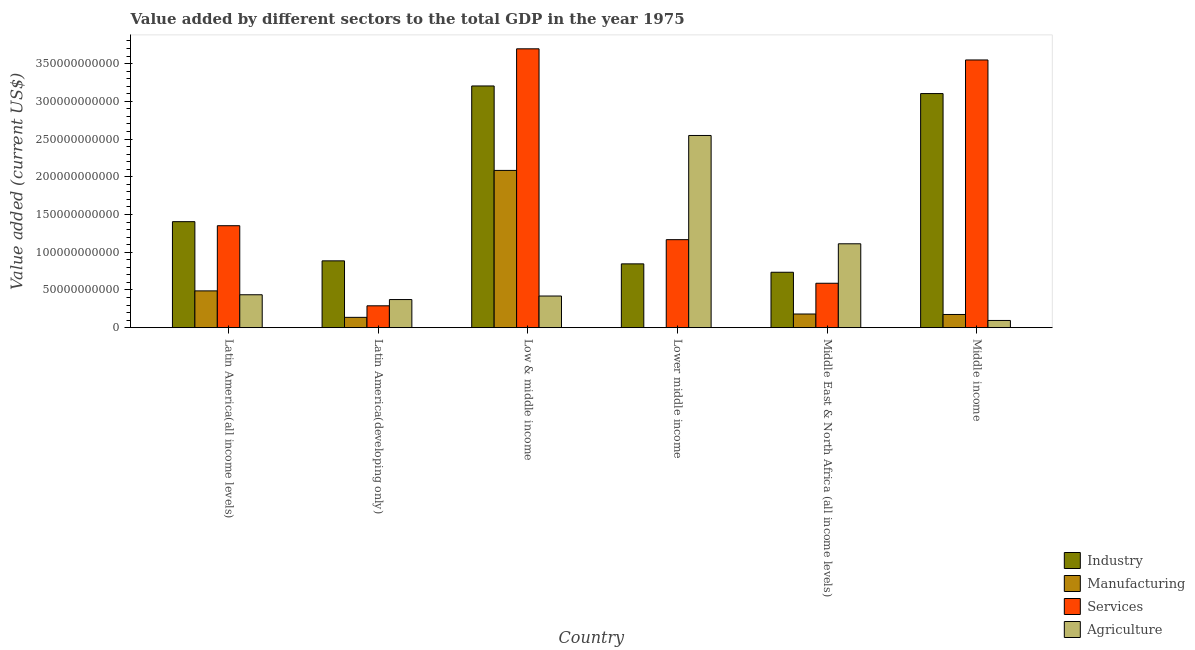How many different coloured bars are there?
Make the answer very short. 4. How many bars are there on the 4th tick from the left?
Your response must be concise. 4. How many bars are there on the 4th tick from the right?
Offer a terse response. 4. What is the label of the 4th group of bars from the left?
Your response must be concise. Lower middle income. In how many cases, is the number of bars for a given country not equal to the number of legend labels?
Offer a very short reply. 0. What is the value added by agricultural sector in Middle income?
Provide a short and direct response. 9.55e+09. Across all countries, what is the maximum value added by services sector?
Your response must be concise. 3.70e+11. Across all countries, what is the minimum value added by manufacturing sector?
Offer a very short reply. 9.84e+07. In which country was the value added by manufacturing sector maximum?
Ensure brevity in your answer.  Low & middle income. In which country was the value added by manufacturing sector minimum?
Offer a terse response. Lower middle income. What is the total value added by manufacturing sector in the graph?
Provide a short and direct response. 3.06e+11. What is the difference between the value added by industrial sector in Latin America(all income levels) and that in Middle East & North Africa (all income levels)?
Give a very brief answer. 6.70e+1. What is the difference between the value added by services sector in Lower middle income and the value added by agricultural sector in Low & middle income?
Provide a succinct answer. 7.47e+1. What is the average value added by manufacturing sector per country?
Keep it short and to the point. 5.11e+1. What is the difference between the value added by manufacturing sector and value added by industrial sector in Lower middle income?
Your answer should be very brief. -8.45e+1. In how many countries, is the value added by services sector greater than 370000000000 US$?
Ensure brevity in your answer.  0. What is the ratio of the value added by industrial sector in Low & middle income to that in Lower middle income?
Keep it short and to the point. 3.79. What is the difference between the highest and the second highest value added by manufacturing sector?
Ensure brevity in your answer.  1.60e+11. What is the difference between the highest and the lowest value added by manufacturing sector?
Keep it short and to the point. 2.08e+11. Is it the case that in every country, the sum of the value added by industrial sector and value added by manufacturing sector is greater than the sum of value added by agricultural sector and value added by services sector?
Provide a short and direct response. Yes. What does the 2nd bar from the left in Low & middle income represents?
Make the answer very short. Manufacturing. What does the 3rd bar from the right in Low & middle income represents?
Your answer should be compact. Manufacturing. Is it the case that in every country, the sum of the value added by industrial sector and value added by manufacturing sector is greater than the value added by services sector?
Make the answer very short. No. How many bars are there?
Your answer should be compact. 24. Are all the bars in the graph horizontal?
Your response must be concise. No. How many countries are there in the graph?
Your answer should be compact. 6. Are the values on the major ticks of Y-axis written in scientific E-notation?
Your answer should be compact. No. Does the graph contain grids?
Keep it short and to the point. No. How are the legend labels stacked?
Offer a very short reply. Vertical. What is the title of the graph?
Ensure brevity in your answer.  Value added by different sectors to the total GDP in the year 1975. Does "Luxembourg" appear as one of the legend labels in the graph?
Give a very brief answer. No. What is the label or title of the Y-axis?
Give a very brief answer. Value added (current US$). What is the Value added (current US$) in Industry in Latin America(all income levels)?
Provide a short and direct response. 1.40e+11. What is the Value added (current US$) of Manufacturing in Latin America(all income levels)?
Ensure brevity in your answer.  4.87e+1. What is the Value added (current US$) in Services in Latin America(all income levels)?
Keep it short and to the point. 1.35e+11. What is the Value added (current US$) of Agriculture in Latin America(all income levels)?
Keep it short and to the point. 4.36e+1. What is the Value added (current US$) of Industry in Latin America(developing only)?
Provide a short and direct response. 8.85e+1. What is the Value added (current US$) in Manufacturing in Latin America(developing only)?
Provide a short and direct response. 1.37e+1. What is the Value added (current US$) of Services in Latin America(developing only)?
Give a very brief answer. 2.90e+1. What is the Value added (current US$) of Agriculture in Latin America(developing only)?
Your answer should be compact. 3.73e+1. What is the Value added (current US$) in Industry in Low & middle income?
Provide a short and direct response. 3.20e+11. What is the Value added (current US$) in Manufacturing in Low & middle income?
Ensure brevity in your answer.  2.08e+11. What is the Value added (current US$) in Services in Low & middle income?
Your answer should be very brief. 3.70e+11. What is the Value added (current US$) of Agriculture in Low & middle income?
Ensure brevity in your answer.  4.19e+1. What is the Value added (current US$) of Industry in Lower middle income?
Give a very brief answer. 8.45e+1. What is the Value added (current US$) in Manufacturing in Lower middle income?
Your answer should be very brief. 9.84e+07. What is the Value added (current US$) in Services in Lower middle income?
Your answer should be compact. 1.17e+11. What is the Value added (current US$) in Agriculture in Lower middle income?
Ensure brevity in your answer.  2.55e+11. What is the Value added (current US$) in Industry in Middle East & North Africa (all income levels)?
Offer a very short reply. 7.34e+1. What is the Value added (current US$) of Manufacturing in Middle East & North Africa (all income levels)?
Make the answer very short. 1.81e+1. What is the Value added (current US$) in Services in Middle East & North Africa (all income levels)?
Give a very brief answer. 5.88e+1. What is the Value added (current US$) of Agriculture in Middle East & North Africa (all income levels)?
Your answer should be very brief. 1.11e+11. What is the Value added (current US$) of Industry in Middle income?
Provide a succinct answer. 3.10e+11. What is the Value added (current US$) of Manufacturing in Middle income?
Your answer should be very brief. 1.75e+1. What is the Value added (current US$) in Services in Middle income?
Your answer should be compact. 3.55e+11. What is the Value added (current US$) in Agriculture in Middle income?
Provide a short and direct response. 9.55e+09. Across all countries, what is the maximum Value added (current US$) in Industry?
Ensure brevity in your answer.  3.20e+11. Across all countries, what is the maximum Value added (current US$) of Manufacturing?
Your answer should be compact. 2.08e+11. Across all countries, what is the maximum Value added (current US$) in Services?
Your answer should be very brief. 3.70e+11. Across all countries, what is the maximum Value added (current US$) of Agriculture?
Keep it short and to the point. 2.55e+11. Across all countries, what is the minimum Value added (current US$) of Industry?
Provide a short and direct response. 7.34e+1. Across all countries, what is the minimum Value added (current US$) in Manufacturing?
Your response must be concise. 9.84e+07. Across all countries, what is the minimum Value added (current US$) of Services?
Your answer should be compact. 2.90e+1. Across all countries, what is the minimum Value added (current US$) in Agriculture?
Ensure brevity in your answer.  9.55e+09. What is the total Value added (current US$) in Industry in the graph?
Offer a terse response. 1.02e+12. What is the total Value added (current US$) of Manufacturing in the graph?
Ensure brevity in your answer.  3.06e+11. What is the total Value added (current US$) of Services in the graph?
Offer a very short reply. 1.06e+12. What is the total Value added (current US$) in Agriculture in the graph?
Offer a terse response. 4.98e+11. What is the difference between the Value added (current US$) in Industry in Latin America(all income levels) and that in Latin America(developing only)?
Your response must be concise. 5.19e+1. What is the difference between the Value added (current US$) of Manufacturing in Latin America(all income levels) and that in Latin America(developing only)?
Keep it short and to the point. 3.51e+1. What is the difference between the Value added (current US$) in Services in Latin America(all income levels) and that in Latin America(developing only)?
Ensure brevity in your answer.  1.06e+11. What is the difference between the Value added (current US$) of Agriculture in Latin America(all income levels) and that in Latin America(developing only)?
Keep it short and to the point. 6.36e+09. What is the difference between the Value added (current US$) in Industry in Latin America(all income levels) and that in Low & middle income?
Offer a terse response. -1.80e+11. What is the difference between the Value added (current US$) in Manufacturing in Latin America(all income levels) and that in Low & middle income?
Give a very brief answer. -1.60e+11. What is the difference between the Value added (current US$) of Services in Latin America(all income levels) and that in Low & middle income?
Offer a very short reply. -2.34e+11. What is the difference between the Value added (current US$) of Agriculture in Latin America(all income levels) and that in Low & middle income?
Offer a very short reply. 1.69e+09. What is the difference between the Value added (current US$) of Industry in Latin America(all income levels) and that in Lower middle income?
Give a very brief answer. 5.59e+1. What is the difference between the Value added (current US$) in Manufacturing in Latin America(all income levels) and that in Lower middle income?
Ensure brevity in your answer.  4.86e+1. What is the difference between the Value added (current US$) of Services in Latin America(all income levels) and that in Lower middle income?
Give a very brief answer. 1.85e+1. What is the difference between the Value added (current US$) of Agriculture in Latin America(all income levels) and that in Lower middle income?
Your response must be concise. -2.11e+11. What is the difference between the Value added (current US$) of Industry in Latin America(all income levels) and that in Middle East & North Africa (all income levels)?
Provide a short and direct response. 6.70e+1. What is the difference between the Value added (current US$) of Manufacturing in Latin America(all income levels) and that in Middle East & North Africa (all income levels)?
Your answer should be compact. 3.06e+1. What is the difference between the Value added (current US$) in Services in Latin America(all income levels) and that in Middle East & North Africa (all income levels)?
Your answer should be very brief. 7.63e+1. What is the difference between the Value added (current US$) of Agriculture in Latin America(all income levels) and that in Middle East & North Africa (all income levels)?
Provide a succinct answer. -6.75e+1. What is the difference between the Value added (current US$) in Industry in Latin America(all income levels) and that in Middle income?
Make the answer very short. -1.70e+11. What is the difference between the Value added (current US$) of Manufacturing in Latin America(all income levels) and that in Middle income?
Your response must be concise. 3.13e+1. What is the difference between the Value added (current US$) in Services in Latin America(all income levels) and that in Middle income?
Your response must be concise. -2.20e+11. What is the difference between the Value added (current US$) in Agriculture in Latin America(all income levels) and that in Middle income?
Offer a terse response. 3.41e+1. What is the difference between the Value added (current US$) of Industry in Latin America(developing only) and that in Low & middle income?
Give a very brief answer. -2.32e+11. What is the difference between the Value added (current US$) in Manufacturing in Latin America(developing only) and that in Low & middle income?
Make the answer very short. -1.95e+11. What is the difference between the Value added (current US$) in Services in Latin America(developing only) and that in Low & middle income?
Your answer should be compact. -3.41e+11. What is the difference between the Value added (current US$) in Agriculture in Latin America(developing only) and that in Low & middle income?
Your response must be concise. -4.66e+09. What is the difference between the Value added (current US$) in Industry in Latin America(developing only) and that in Lower middle income?
Provide a succinct answer. 4.00e+09. What is the difference between the Value added (current US$) in Manufacturing in Latin America(developing only) and that in Lower middle income?
Provide a succinct answer. 1.36e+1. What is the difference between the Value added (current US$) of Services in Latin America(developing only) and that in Lower middle income?
Your answer should be very brief. -8.77e+1. What is the difference between the Value added (current US$) of Agriculture in Latin America(developing only) and that in Lower middle income?
Your answer should be very brief. -2.17e+11. What is the difference between the Value added (current US$) of Industry in Latin America(developing only) and that in Middle East & North Africa (all income levels)?
Your answer should be very brief. 1.51e+1. What is the difference between the Value added (current US$) of Manufacturing in Latin America(developing only) and that in Middle East & North Africa (all income levels)?
Your response must be concise. -4.45e+09. What is the difference between the Value added (current US$) of Services in Latin America(developing only) and that in Middle East & North Africa (all income levels)?
Give a very brief answer. -2.99e+1. What is the difference between the Value added (current US$) of Agriculture in Latin America(developing only) and that in Middle East & North Africa (all income levels)?
Give a very brief answer. -7.39e+1. What is the difference between the Value added (current US$) in Industry in Latin America(developing only) and that in Middle income?
Ensure brevity in your answer.  -2.22e+11. What is the difference between the Value added (current US$) in Manufacturing in Latin America(developing only) and that in Middle income?
Ensure brevity in your answer.  -3.83e+09. What is the difference between the Value added (current US$) in Services in Latin America(developing only) and that in Middle income?
Ensure brevity in your answer.  -3.26e+11. What is the difference between the Value added (current US$) in Agriculture in Latin America(developing only) and that in Middle income?
Your answer should be very brief. 2.77e+1. What is the difference between the Value added (current US$) of Industry in Low & middle income and that in Lower middle income?
Make the answer very short. 2.36e+11. What is the difference between the Value added (current US$) of Manufacturing in Low & middle income and that in Lower middle income?
Provide a short and direct response. 2.08e+11. What is the difference between the Value added (current US$) in Services in Low & middle income and that in Lower middle income?
Your answer should be very brief. 2.53e+11. What is the difference between the Value added (current US$) in Agriculture in Low & middle income and that in Lower middle income?
Your response must be concise. -2.13e+11. What is the difference between the Value added (current US$) of Industry in Low & middle income and that in Middle East & North Africa (all income levels)?
Make the answer very short. 2.47e+11. What is the difference between the Value added (current US$) of Manufacturing in Low & middle income and that in Middle East & North Africa (all income levels)?
Provide a succinct answer. 1.90e+11. What is the difference between the Value added (current US$) of Services in Low & middle income and that in Middle East & North Africa (all income levels)?
Provide a short and direct response. 3.11e+11. What is the difference between the Value added (current US$) in Agriculture in Low & middle income and that in Middle East & North Africa (all income levels)?
Offer a very short reply. -6.92e+1. What is the difference between the Value added (current US$) in Industry in Low & middle income and that in Middle income?
Make the answer very short. 1.01e+1. What is the difference between the Value added (current US$) of Manufacturing in Low & middle income and that in Middle income?
Give a very brief answer. 1.91e+11. What is the difference between the Value added (current US$) in Services in Low & middle income and that in Middle income?
Your answer should be compact. 1.48e+1. What is the difference between the Value added (current US$) of Agriculture in Low & middle income and that in Middle income?
Provide a short and direct response. 3.24e+1. What is the difference between the Value added (current US$) in Industry in Lower middle income and that in Middle East & North Africa (all income levels)?
Provide a succinct answer. 1.11e+1. What is the difference between the Value added (current US$) in Manufacturing in Lower middle income and that in Middle East & North Africa (all income levels)?
Offer a terse response. -1.80e+1. What is the difference between the Value added (current US$) of Services in Lower middle income and that in Middle East & North Africa (all income levels)?
Your answer should be compact. 5.78e+1. What is the difference between the Value added (current US$) in Agriculture in Lower middle income and that in Middle East & North Africa (all income levels)?
Offer a very short reply. 1.44e+11. What is the difference between the Value added (current US$) of Industry in Lower middle income and that in Middle income?
Provide a succinct answer. -2.26e+11. What is the difference between the Value added (current US$) of Manufacturing in Lower middle income and that in Middle income?
Offer a very short reply. -1.74e+1. What is the difference between the Value added (current US$) in Services in Lower middle income and that in Middle income?
Your response must be concise. -2.38e+11. What is the difference between the Value added (current US$) of Agriculture in Lower middle income and that in Middle income?
Provide a succinct answer. 2.45e+11. What is the difference between the Value added (current US$) of Industry in Middle East & North Africa (all income levels) and that in Middle income?
Your answer should be very brief. -2.37e+11. What is the difference between the Value added (current US$) in Manufacturing in Middle East & North Africa (all income levels) and that in Middle income?
Provide a succinct answer. 6.23e+08. What is the difference between the Value added (current US$) of Services in Middle East & North Africa (all income levels) and that in Middle income?
Your response must be concise. -2.96e+11. What is the difference between the Value added (current US$) in Agriculture in Middle East & North Africa (all income levels) and that in Middle income?
Provide a short and direct response. 1.02e+11. What is the difference between the Value added (current US$) of Industry in Latin America(all income levels) and the Value added (current US$) of Manufacturing in Latin America(developing only)?
Provide a succinct answer. 1.27e+11. What is the difference between the Value added (current US$) in Industry in Latin America(all income levels) and the Value added (current US$) in Services in Latin America(developing only)?
Your answer should be very brief. 1.12e+11. What is the difference between the Value added (current US$) in Industry in Latin America(all income levels) and the Value added (current US$) in Agriculture in Latin America(developing only)?
Ensure brevity in your answer.  1.03e+11. What is the difference between the Value added (current US$) in Manufacturing in Latin America(all income levels) and the Value added (current US$) in Services in Latin America(developing only)?
Your response must be concise. 1.98e+1. What is the difference between the Value added (current US$) in Manufacturing in Latin America(all income levels) and the Value added (current US$) in Agriculture in Latin America(developing only)?
Keep it short and to the point. 1.15e+1. What is the difference between the Value added (current US$) in Services in Latin America(all income levels) and the Value added (current US$) in Agriculture in Latin America(developing only)?
Offer a very short reply. 9.79e+1. What is the difference between the Value added (current US$) of Industry in Latin America(all income levels) and the Value added (current US$) of Manufacturing in Low & middle income?
Ensure brevity in your answer.  -6.79e+1. What is the difference between the Value added (current US$) in Industry in Latin America(all income levels) and the Value added (current US$) in Services in Low & middle income?
Your response must be concise. -2.29e+11. What is the difference between the Value added (current US$) in Industry in Latin America(all income levels) and the Value added (current US$) in Agriculture in Low & middle income?
Offer a terse response. 9.86e+1. What is the difference between the Value added (current US$) of Manufacturing in Latin America(all income levels) and the Value added (current US$) of Services in Low & middle income?
Keep it short and to the point. -3.21e+11. What is the difference between the Value added (current US$) in Manufacturing in Latin America(all income levels) and the Value added (current US$) in Agriculture in Low & middle income?
Offer a very short reply. 6.82e+09. What is the difference between the Value added (current US$) of Services in Latin America(all income levels) and the Value added (current US$) of Agriculture in Low & middle income?
Offer a terse response. 9.32e+1. What is the difference between the Value added (current US$) of Industry in Latin America(all income levels) and the Value added (current US$) of Manufacturing in Lower middle income?
Offer a very short reply. 1.40e+11. What is the difference between the Value added (current US$) of Industry in Latin America(all income levels) and the Value added (current US$) of Services in Lower middle income?
Make the answer very short. 2.39e+1. What is the difference between the Value added (current US$) of Industry in Latin America(all income levels) and the Value added (current US$) of Agriculture in Lower middle income?
Your answer should be compact. -1.14e+11. What is the difference between the Value added (current US$) of Manufacturing in Latin America(all income levels) and the Value added (current US$) of Services in Lower middle income?
Keep it short and to the point. -6.79e+1. What is the difference between the Value added (current US$) in Manufacturing in Latin America(all income levels) and the Value added (current US$) in Agriculture in Lower middle income?
Offer a terse response. -2.06e+11. What is the difference between the Value added (current US$) of Services in Latin America(all income levels) and the Value added (current US$) of Agriculture in Lower middle income?
Keep it short and to the point. -1.20e+11. What is the difference between the Value added (current US$) in Industry in Latin America(all income levels) and the Value added (current US$) in Manufacturing in Middle East & North Africa (all income levels)?
Give a very brief answer. 1.22e+11. What is the difference between the Value added (current US$) of Industry in Latin America(all income levels) and the Value added (current US$) of Services in Middle East & North Africa (all income levels)?
Your response must be concise. 8.16e+1. What is the difference between the Value added (current US$) of Industry in Latin America(all income levels) and the Value added (current US$) of Agriculture in Middle East & North Africa (all income levels)?
Your response must be concise. 2.93e+1. What is the difference between the Value added (current US$) in Manufacturing in Latin America(all income levels) and the Value added (current US$) in Services in Middle East & North Africa (all income levels)?
Your answer should be compact. -1.01e+1. What is the difference between the Value added (current US$) in Manufacturing in Latin America(all income levels) and the Value added (current US$) in Agriculture in Middle East & North Africa (all income levels)?
Your answer should be compact. -6.24e+1. What is the difference between the Value added (current US$) of Services in Latin America(all income levels) and the Value added (current US$) of Agriculture in Middle East & North Africa (all income levels)?
Ensure brevity in your answer.  2.40e+1. What is the difference between the Value added (current US$) in Industry in Latin America(all income levels) and the Value added (current US$) in Manufacturing in Middle income?
Offer a very short reply. 1.23e+11. What is the difference between the Value added (current US$) of Industry in Latin America(all income levels) and the Value added (current US$) of Services in Middle income?
Provide a short and direct response. -2.14e+11. What is the difference between the Value added (current US$) in Industry in Latin America(all income levels) and the Value added (current US$) in Agriculture in Middle income?
Make the answer very short. 1.31e+11. What is the difference between the Value added (current US$) of Manufacturing in Latin America(all income levels) and the Value added (current US$) of Services in Middle income?
Provide a short and direct response. -3.06e+11. What is the difference between the Value added (current US$) in Manufacturing in Latin America(all income levels) and the Value added (current US$) in Agriculture in Middle income?
Give a very brief answer. 3.92e+1. What is the difference between the Value added (current US$) of Services in Latin America(all income levels) and the Value added (current US$) of Agriculture in Middle income?
Offer a very short reply. 1.26e+11. What is the difference between the Value added (current US$) in Industry in Latin America(developing only) and the Value added (current US$) in Manufacturing in Low & middle income?
Your answer should be compact. -1.20e+11. What is the difference between the Value added (current US$) of Industry in Latin America(developing only) and the Value added (current US$) of Services in Low & middle income?
Your response must be concise. -2.81e+11. What is the difference between the Value added (current US$) in Industry in Latin America(developing only) and the Value added (current US$) in Agriculture in Low & middle income?
Offer a terse response. 4.66e+1. What is the difference between the Value added (current US$) in Manufacturing in Latin America(developing only) and the Value added (current US$) in Services in Low & middle income?
Ensure brevity in your answer.  -3.56e+11. What is the difference between the Value added (current US$) of Manufacturing in Latin America(developing only) and the Value added (current US$) of Agriculture in Low & middle income?
Offer a terse response. -2.83e+1. What is the difference between the Value added (current US$) in Services in Latin America(developing only) and the Value added (current US$) in Agriculture in Low & middle income?
Keep it short and to the point. -1.30e+1. What is the difference between the Value added (current US$) in Industry in Latin America(developing only) and the Value added (current US$) in Manufacturing in Lower middle income?
Your answer should be very brief. 8.85e+1. What is the difference between the Value added (current US$) in Industry in Latin America(developing only) and the Value added (current US$) in Services in Lower middle income?
Provide a succinct answer. -2.81e+1. What is the difference between the Value added (current US$) in Industry in Latin America(developing only) and the Value added (current US$) in Agriculture in Lower middle income?
Keep it short and to the point. -1.66e+11. What is the difference between the Value added (current US$) in Manufacturing in Latin America(developing only) and the Value added (current US$) in Services in Lower middle income?
Your response must be concise. -1.03e+11. What is the difference between the Value added (current US$) of Manufacturing in Latin America(developing only) and the Value added (current US$) of Agriculture in Lower middle income?
Your answer should be compact. -2.41e+11. What is the difference between the Value added (current US$) of Services in Latin America(developing only) and the Value added (current US$) of Agriculture in Lower middle income?
Keep it short and to the point. -2.26e+11. What is the difference between the Value added (current US$) of Industry in Latin America(developing only) and the Value added (current US$) of Manufacturing in Middle East & North Africa (all income levels)?
Provide a succinct answer. 7.04e+1. What is the difference between the Value added (current US$) of Industry in Latin America(developing only) and the Value added (current US$) of Services in Middle East & North Africa (all income levels)?
Keep it short and to the point. 2.97e+1. What is the difference between the Value added (current US$) of Industry in Latin America(developing only) and the Value added (current US$) of Agriculture in Middle East & North Africa (all income levels)?
Offer a very short reply. -2.26e+1. What is the difference between the Value added (current US$) in Manufacturing in Latin America(developing only) and the Value added (current US$) in Services in Middle East & North Africa (all income levels)?
Offer a terse response. -4.52e+1. What is the difference between the Value added (current US$) in Manufacturing in Latin America(developing only) and the Value added (current US$) in Agriculture in Middle East & North Africa (all income levels)?
Keep it short and to the point. -9.75e+1. What is the difference between the Value added (current US$) of Services in Latin America(developing only) and the Value added (current US$) of Agriculture in Middle East & North Africa (all income levels)?
Keep it short and to the point. -8.22e+1. What is the difference between the Value added (current US$) of Industry in Latin America(developing only) and the Value added (current US$) of Manufacturing in Middle income?
Ensure brevity in your answer.  7.11e+1. What is the difference between the Value added (current US$) in Industry in Latin America(developing only) and the Value added (current US$) in Services in Middle income?
Offer a terse response. -2.66e+11. What is the difference between the Value added (current US$) of Industry in Latin America(developing only) and the Value added (current US$) of Agriculture in Middle income?
Provide a succinct answer. 7.90e+1. What is the difference between the Value added (current US$) of Manufacturing in Latin America(developing only) and the Value added (current US$) of Services in Middle income?
Make the answer very short. -3.41e+11. What is the difference between the Value added (current US$) of Manufacturing in Latin America(developing only) and the Value added (current US$) of Agriculture in Middle income?
Offer a very short reply. 4.10e+09. What is the difference between the Value added (current US$) of Services in Latin America(developing only) and the Value added (current US$) of Agriculture in Middle income?
Your answer should be compact. 1.94e+1. What is the difference between the Value added (current US$) of Industry in Low & middle income and the Value added (current US$) of Manufacturing in Lower middle income?
Offer a terse response. 3.20e+11. What is the difference between the Value added (current US$) in Industry in Low & middle income and the Value added (current US$) in Services in Lower middle income?
Keep it short and to the point. 2.04e+11. What is the difference between the Value added (current US$) of Industry in Low & middle income and the Value added (current US$) of Agriculture in Lower middle income?
Make the answer very short. 6.56e+1. What is the difference between the Value added (current US$) in Manufacturing in Low & middle income and the Value added (current US$) in Services in Lower middle income?
Make the answer very short. 9.18e+1. What is the difference between the Value added (current US$) of Manufacturing in Low & middle income and the Value added (current US$) of Agriculture in Lower middle income?
Your response must be concise. -4.63e+1. What is the difference between the Value added (current US$) in Services in Low & middle income and the Value added (current US$) in Agriculture in Lower middle income?
Make the answer very short. 1.15e+11. What is the difference between the Value added (current US$) of Industry in Low & middle income and the Value added (current US$) of Manufacturing in Middle East & North Africa (all income levels)?
Make the answer very short. 3.02e+11. What is the difference between the Value added (current US$) in Industry in Low & middle income and the Value added (current US$) in Services in Middle East & North Africa (all income levels)?
Provide a short and direct response. 2.61e+11. What is the difference between the Value added (current US$) of Industry in Low & middle income and the Value added (current US$) of Agriculture in Middle East & North Africa (all income levels)?
Your response must be concise. 2.09e+11. What is the difference between the Value added (current US$) in Manufacturing in Low & middle income and the Value added (current US$) in Services in Middle East & North Africa (all income levels)?
Make the answer very short. 1.50e+11. What is the difference between the Value added (current US$) in Manufacturing in Low & middle income and the Value added (current US$) in Agriculture in Middle East & North Africa (all income levels)?
Keep it short and to the point. 9.72e+1. What is the difference between the Value added (current US$) in Services in Low & middle income and the Value added (current US$) in Agriculture in Middle East & North Africa (all income levels)?
Offer a very short reply. 2.58e+11. What is the difference between the Value added (current US$) in Industry in Low & middle income and the Value added (current US$) in Manufacturing in Middle income?
Provide a short and direct response. 3.03e+11. What is the difference between the Value added (current US$) of Industry in Low & middle income and the Value added (current US$) of Services in Middle income?
Your answer should be compact. -3.45e+1. What is the difference between the Value added (current US$) of Industry in Low & middle income and the Value added (current US$) of Agriculture in Middle income?
Keep it short and to the point. 3.11e+11. What is the difference between the Value added (current US$) of Manufacturing in Low & middle income and the Value added (current US$) of Services in Middle income?
Provide a succinct answer. -1.46e+11. What is the difference between the Value added (current US$) in Manufacturing in Low & middle income and the Value added (current US$) in Agriculture in Middle income?
Give a very brief answer. 1.99e+11. What is the difference between the Value added (current US$) of Services in Low & middle income and the Value added (current US$) of Agriculture in Middle income?
Give a very brief answer. 3.60e+11. What is the difference between the Value added (current US$) in Industry in Lower middle income and the Value added (current US$) in Manufacturing in Middle East & North Africa (all income levels)?
Your response must be concise. 6.64e+1. What is the difference between the Value added (current US$) in Industry in Lower middle income and the Value added (current US$) in Services in Middle East & North Africa (all income levels)?
Your answer should be compact. 2.57e+1. What is the difference between the Value added (current US$) in Industry in Lower middle income and the Value added (current US$) in Agriculture in Middle East & North Africa (all income levels)?
Provide a short and direct response. -2.66e+1. What is the difference between the Value added (current US$) in Manufacturing in Lower middle income and the Value added (current US$) in Services in Middle East & North Africa (all income levels)?
Your response must be concise. -5.87e+1. What is the difference between the Value added (current US$) of Manufacturing in Lower middle income and the Value added (current US$) of Agriculture in Middle East & North Africa (all income levels)?
Make the answer very short. -1.11e+11. What is the difference between the Value added (current US$) in Services in Lower middle income and the Value added (current US$) in Agriculture in Middle East & North Africa (all income levels)?
Offer a very short reply. 5.47e+09. What is the difference between the Value added (current US$) of Industry in Lower middle income and the Value added (current US$) of Manufacturing in Middle income?
Your answer should be very brief. 6.71e+1. What is the difference between the Value added (current US$) of Industry in Lower middle income and the Value added (current US$) of Services in Middle income?
Give a very brief answer. -2.70e+11. What is the difference between the Value added (current US$) in Industry in Lower middle income and the Value added (current US$) in Agriculture in Middle income?
Make the answer very short. 7.50e+1. What is the difference between the Value added (current US$) of Manufacturing in Lower middle income and the Value added (current US$) of Services in Middle income?
Ensure brevity in your answer.  -3.55e+11. What is the difference between the Value added (current US$) in Manufacturing in Lower middle income and the Value added (current US$) in Agriculture in Middle income?
Give a very brief answer. -9.45e+09. What is the difference between the Value added (current US$) in Services in Lower middle income and the Value added (current US$) in Agriculture in Middle income?
Ensure brevity in your answer.  1.07e+11. What is the difference between the Value added (current US$) of Industry in Middle East & North Africa (all income levels) and the Value added (current US$) of Manufacturing in Middle income?
Your answer should be very brief. 5.59e+1. What is the difference between the Value added (current US$) of Industry in Middle East & North Africa (all income levels) and the Value added (current US$) of Services in Middle income?
Keep it short and to the point. -2.81e+11. What is the difference between the Value added (current US$) of Industry in Middle East & North Africa (all income levels) and the Value added (current US$) of Agriculture in Middle income?
Offer a terse response. 6.39e+1. What is the difference between the Value added (current US$) of Manufacturing in Middle East & North Africa (all income levels) and the Value added (current US$) of Services in Middle income?
Your answer should be compact. -3.37e+11. What is the difference between the Value added (current US$) in Manufacturing in Middle East & North Africa (all income levels) and the Value added (current US$) in Agriculture in Middle income?
Your response must be concise. 8.55e+09. What is the difference between the Value added (current US$) in Services in Middle East & North Africa (all income levels) and the Value added (current US$) in Agriculture in Middle income?
Offer a terse response. 4.93e+1. What is the average Value added (current US$) of Industry per country?
Ensure brevity in your answer.  1.70e+11. What is the average Value added (current US$) in Manufacturing per country?
Your answer should be very brief. 5.11e+1. What is the average Value added (current US$) in Services per country?
Your answer should be very brief. 1.77e+11. What is the average Value added (current US$) in Agriculture per country?
Give a very brief answer. 8.30e+1. What is the difference between the Value added (current US$) of Industry and Value added (current US$) of Manufacturing in Latin America(all income levels)?
Offer a very short reply. 9.17e+1. What is the difference between the Value added (current US$) of Industry and Value added (current US$) of Services in Latin America(all income levels)?
Give a very brief answer. 5.36e+09. What is the difference between the Value added (current US$) of Industry and Value added (current US$) of Agriculture in Latin America(all income levels)?
Ensure brevity in your answer.  9.69e+1. What is the difference between the Value added (current US$) of Manufacturing and Value added (current US$) of Services in Latin America(all income levels)?
Your answer should be compact. -8.64e+1. What is the difference between the Value added (current US$) in Manufacturing and Value added (current US$) in Agriculture in Latin America(all income levels)?
Ensure brevity in your answer.  5.13e+09. What is the difference between the Value added (current US$) of Services and Value added (current US$) of Agriculture in Latin America(all income levels)?
Keep it short and to the point. 9.15e+1. What is the difference between the Value added (current US$) in Industry and Value added (current US$) in Manufacturing in Latin America(developing only)?
Provide a succinct answer. 7.49e+1. What is the difference between the Value added (current US$) of Industry and Value added (current US$) of Services in Latin America(developing only)?
Keep it short and to the point. 5.96e+1. What is the difference between the Value added (current US$) of Industry and Value added (current US$) of Agriculture in Latin America(developing only)?
Keep it short and to the point. 5.13e+1. What is the difference between the Value added (current US$) in Manufacturing and Value added (current US$) in Services in Latin America(developing only)?
Your answer should be compact. -1.53e+1. What is the difference between the Value added (current US$) of Manufacturing and Value added (current US$) of Agriculture in Latin America(developing only)?
Provide a short and direct response. -2.36e+1. What is the difference between the Value added (current US$) of Services and Value added (current US$) of Agriculture in Latin America(developing only)?
Make the answer very short. -8.30e+09. What is the difference between the Value added (current US$) in Industry and Value added (current US$) in Manufacturing in Low & middle income?
Your answer should be compact. 1.12e+11. What is the difference between the Value added (current US$) in Industry and Value added (current US$) in Services in Low & middle income?
Provide a succinct answer. -4.92e+1. What is the difference between the Value added (current US$) of Industry and Value added (current US$) of Agriculture in Low & middle income?
Offer a terse response. 2.78e+11. What is the difference between the Value added (current US$) in Manufacturing and Value added (current US$) in Services in Low & middle income?
Your answer should be compact. -1.61e+11. What is the difference between the Value added (current US$) in Manufacturing and Value added (current US$) in Agriculture in Low & middle income?
Your response must be concise. 1.66e+11. What is the difference between the Value added (current US$) of Services and Value added (current US$) of Agriculture in Low & middle income?
Make the answer very short. 3.28e+11. What is the difference between the Value added (current US$) in Industry and Value added (current US$) in Manufacturing in Lower middle income?
Your answer should be very brief. 8.45e+1. What is the difference between the Value added (current US$) of Industry and Value added (current US$) of Services in Lower middle income?
Make the answer very short. -3.21e+1. What is the difference between the Value added (current US$) of Industry and Value added (current US$) of Agriculture in Lower middle income?
Ensure brevity in your answer.  -1.70e+11. What is the difference between the Value added (current US$) in Manufacturing and Value added (current US$) in Services in Lower middle income?
Offer a terse response. -1.17e+11. What is the difference between the Value added (current US$) of Manufacturing and Value added (current US$) of Agriculture in Lower middle income?
Your answer should be very brief. -2.55e+11. What is the difference between the Value added (current US$) of Services and Value added (current US$) of Agriculture in Lower middle income?
Your answer should be compact. -1.38e+11. What is the difference between the Value added (current US$) in Industry and Value added (current US$) in Manufacturing in Middle East & North Africa (all income levels)?
Provide a short and direct response. 5.53e+1. What is the difference between the Value added (current US$) of Industry and Value added (current US$) of Services in Middle East & North Africa (all income levels)?
Provide a succinct answer. 1.46e+1. What is the difference between the Value added (current US$) in Industry and Value added (current US$) in Agriculture in Middle East & North Africa (all income levels)?
Provide a short and direct response. -3.77e+1. What is the difference between the Value added (current US$) in Manufacturing and Value added (current US$) in Services in Middle East & North Africa (all income levels)?
Provide a short and direct response. -4.07e+1. What is the difference between the Value added (current US$) in Manufacturing and Value added (current US$) in Agriculture in Middle East & North Africa (all income levels)?
Offer a terse response. -9.30e+1. What is the difference between the Value added (current US$) of Services and Value added (current US$) of Agriculture in Middle East & North Africa (all income levels)?
Your answer should be compact. -5.23e+1. What is the difference between the Value added (current US$) in Industry and Value added (current US$) in Manufacturing in Middle income?
Offer a very short reply. 2.93e+11. What is the difference between the Value added (current US$) in Industry and Value added (current US$) in Services in Middle income?
Give a very brief answer. -4.45e+1. What is the difference between the Value added (current US$) of Industry and Value added (current US$) of Agriculture in Middle income?
Keep it short and to the point. 3.01e+11. What is the difference between the Value added (current US$) in Manufacturing and Value added (current US$) in Services in Middle income?
Ensure brevity in your answer.  -3.37e+11. What is the difference between the Value added (current US$) of Manufacturing and Value added (current US$) of Agriculture in Middle income?
Your answer should be compact. 7.93e+09. What is the difference between the Value added (current US$) in Services and Value added (current US$) in Agriculture in Middle income?
Offer a very short reply. 3.45e+11. What is the ratio of the Value added (current US$) in Industry in Latin America(all income levels) to that in Latin America(developing only)?
Make the answer very short. 1.59. What is the ratio of the Value added (current US$) of Manufacturing in Latin America(all income levels) to that in Latin America(developing only)?
Offer a very short reply. 3.57. What is the ratio of the Value added (current US$) of Services in Latin America(all income levels) to that in Latin America(developing only)?
Offer a very short reply. 4.67. What is the ratio of the Value added (current US$) in Agriculture in Latin America(all income levels) to that in Latin America(developing only)?
Your answer should be compact. 1.17. What is the ratio of the Value added (current US$) in Industry in Latin America(all income levels) to that in Low & middle income?
Your response must be concise. 0.44. What is the ratio of the Value added (current US$) of Manufacturing in Latin America(all income levels) to that in Low & middle income?
Your answer should be compact. 0.23. What is the ratio of the Value added (current US$) in Services in Latin America(all income levels) to that in Low & middle income?
Give a very brief answer. 0.37. What is the ratio of the Value added (current US$) in Agriculture in Latin America(all income levels) to that in Low & middle income?
Your response must be concise. 1.04. What is the ratio of the Value added (current US$) of Industry in Latin America(all income levels) to that in Lower middle income?
Ensure brevity in your answer.  1.66. What is the ratio of the Value added (current US$) of Manufacturing in Latin America(all income levels) to that in Lower middle income?
Ensure brevity in your answer.  495.16. What is the ratio of the Value added (current US$) in Services in Latin America(all income levels) to that in Lower middle income?
Your response must be concise. 1.16. What is the ratio of the Value added (current US$) of Agriculture in Latin America(all income levels) to that in Lower middle income?
Offer a terse response. 0.17. What is the ratio of the Value added (current US$) in Industry in Latin America(all income levels) to that in Middle East & North Africa (all income levels)?
Give a very brief answer. 1.91. What is the ratio of the Value added (current US$) of Manufacturing in Latin America(all income levels) to that in Middle East & North Africa (all income levels)?
Your answer should be compact. 2.69. What is the ratio of the Value added (current US$) in Services in Latin America(all income levels) to that in Middle East & North Africa (all income levels)?
Your answer should be very brief. 2.3. What is the ratio of the Value added (current US$) of Agriculture in Latin America(all income levels) to that in Middle East & North Africa (all income levels)?
Offer a very short reply. 0.39. What is the ratio of the Value added (current US$) in Industry in Latin America(all income levels) to that in Middle income?
Provide a short and direct response. 0.45. What is the ratio of the Value added (current US$) of Manufacturing in Latin America(all income levels) to that in Middle income?
Ensure brevity in your answer.  2.79. What is the ratio of the Value added (current US$) of Services in Latin America(all income levels) to that in Middle income?
Ensure brevity in your answer.  0.38. What is the ratio of the Value added (current US$) of Agriculture in Latin America(all income levels) to that in Middle income?
Your response must be concise. 4.57. What is the ratio of the Value added (current US$) in Industry in Latin America(developing only) to that in Low & middle income?
Offer a terse response. 0.28. What is the ratio of the Value added (current US$) of Manufacturing in Latin America(developing only) to that in Low & middle income?
Offer a very short reply. 0.07. What is the ratio of the Value added (current US$) in Services in Latin America(developing only) to that in Low & middle income?
Give a very brief answer. 0.08. What is the ratio of the Value added (current US$) of Agriculture in Latin America(developing only) to that in Low & middle income?
Ensure brevity in your answer.  0.89. What is the ratio of the Value added (current US$) in Industry in Latin America(developing only) to that in Lower middle income?
Give a very brief answer. 1.05. What is the ratio of the Value added (current US$) of Manufacturing in Latin America(developing only) to that in Lower middle income?
Provide a short and direct response. 138.73. What is the ratio of the Value added (current US$) of Services in Latin America(developing only) to that in Lower middle income?
Offer a very short reply. 0.25. What is the ratio of the Value added (current US$) in Agriculture in Latin America(developing only) to that in Lower middle income?
Your answer should be very brief. 0.15. What is the ratio of the Value added (current US$) in Industry in Latin America(developing only) to that in Middle East & North Africa (all income levels)?
Keep it short and to the point. 1.21. What is the ratio of the Value added (current US$) of Manufacturing in Latin America(developing only) to that in Middle East & North Africa (all income levels)?
Ensure brevity in your answer.  0.75. What is the ratio of the Value added (current US$) of Services in Latin America(developing only) to that in Middle East & North Africa (all income levels)?
Your answer should be compact. 0.49. What is the ratio of the Value added (current US$) in Agriculture in Latin America(developing only) to that in Middle East & North Africa (all income levels)?
Provide a succinct answer. 0.34. What is the ratio of the Value added (current US$) in Industry in Latin America(developing only) to that in Middle income?
Offer a terse response. 0.29. What is the ratio of the Value added (current US$) in Manufacturing in Latin America(developing only) to that in Middle income?
Make the answer very short. 0.78. What is the ratio of the Value added (current US$) in Services in Latin America(developing only) to that in Middle income?
Provide a short and direct response. 0.08. What is the ratio of the Value added (current US$) in Agriculture in Latin America(developing only) to that in Middle income?
Ensure brevity in your answer.  3.9. What is the ratio of the Value added (current US$) in Industry in Low & middle income to that in Lower middle income?
Keep it short and to the point. 3.79. What is the ratio of the Value added (current US$) in Manufacturing in Low & middle income to that in Lower middle income?
Give a very brief answer. 2117.07. What is the ratio of the Value added (current US$) of Services in Low & middle income to that in Lower middle income?
Offer a very short reply. 3.17. What is the ratio of the Value added (current US$) of Agriculture in Low & middle income to that in Lower middle income?
Offer a very short reply. 0.16. What is the ratio of the Value added (current US$) of Industry in Low & middle income to that in Middle East & North Africa (all income levels)?
Give a very brief answer. 4.36. What is the ratio of the Value added (current US$) in Manufacturing in Low & middle income to that in Middle East & North Africa (all income levels)?
Offer a very short reply. 11.51. What is the ratio of the Value added (current US$) of Services in Low & middle income to that in Middle East & North Africa (all income levels)?
Offer a very short reply. 6.28. What is the ratio of the Value added (current US$) of Agriculture in Low & middle income to that in Middle East & North Africa (all income levels)?
Give a very brief answer. 0.38. What is the ratio of the Value added (current US$) of Industry in Low & middle income to that in Middle income?
Ensure brevity in your answer.  1.03. What is the ratio of the Value added (current US$) in Manufacturing in Low & middle income to that in Middle income?
Your answer should be very brief. 11.92. What is the ratio of the Value added (current US$) of Services in Low & middle income to that in Middle income?
Your answer should be very brief. 1.04. What is the ratio of the Value added (current US$) in Agriculture in Low & middle income to that in Middle income?
Provide a short and direct response. 4.39. What is the ratio of the Value added (current US$) of Industry in Lower middle income to that in Middle East & North Africa (all income levels)?
Ensure brevity in your answer.  1.15. What is the ratio of the Value added (current US$) of Manufacturing in Lower middle income to that in Middle East & North Africa (all income levels)?
Keep it short and to the point. 0.01. What is the ratio of the Value added (current US$) in Services in Lower middle income to that in Middle East & North Africa (all income levels)?
Your response must be concise. 1.98. What is the ratio of the Value added (current US$) of Agriculture in Lower middle income to that in Middle East & North Africa (all income levels)?
Your answer should be compact. 2.29. What is the ratio of the Value added (current US$) of Industry in Lower middle income to that in Middle income?
Your answer should be compact. 0.27. What is the ratio of the Value added (current US$) in Manufacturing in Lower middle income to that in Middle income?
Make the answer very short. 0.01. What is the ratio of the Value added (current US$) of Services in Lower middle income to that in Middle income?
Your answer should be compact. 0.33. What is the ratio of the Value added (current US$) of Agriculture in Lower middle income to that in Middle income?
Offer a very short reply. 26.66. What is the ratio of the Value added (current US$) in Industry in Middle East & North Africa (all income levels) to that in Middle income?
Provide a short and direct response. 0.24. What is the ratio of the Value added (current US$) in Manufacturing in Middle East & North Africa (all income levels) to that in Middle income?
Offer a terse response. 1.04. What is the ratio of the Value added (current US$) of Services in Middle East & North Africa (all income levels) to that in Middle income?
Give a very brief answer. 0.17. What is the ratio of the Value added (current US$) of Agriculture in Middle East & North Africa (all income levels) to that in Middle income?
Your answer should be compact. 11.64. What is the difference between the highest and the second highest Value added (current US$) in Industry?
Ensure brevity in your answer.  1.01e+1. What is the difference between the highest and the second highest Value added (current US$) of Manufacturing?
Your answer should be compact. 1.60e+11. What is the difference between the highest and the second highest Value added (current US$) of Services?
Offer a very short reply. 1.48e+1. What is the difference between the highest and the second highest Value added (current US$) of Agriculture?
Offer a very short reply. 1.44e+11. What is the difference between the highest and the lowest Value added (current US$) of Industry?
Your answer should be compact. 2.47e+11. What is the difference between the highest and the lowest Value added (current US$) of Manufacturing?
Make the answer very short. 2.08e+11. What is the difference between the highest and the lowest Value added (current US$) in Services?
Your answer should be very brief. 3.41e+11. What is the difference between the highest and the lowest Value added (current US$) of Agriculture?
Offer a very short reply. 2.45e+11. 